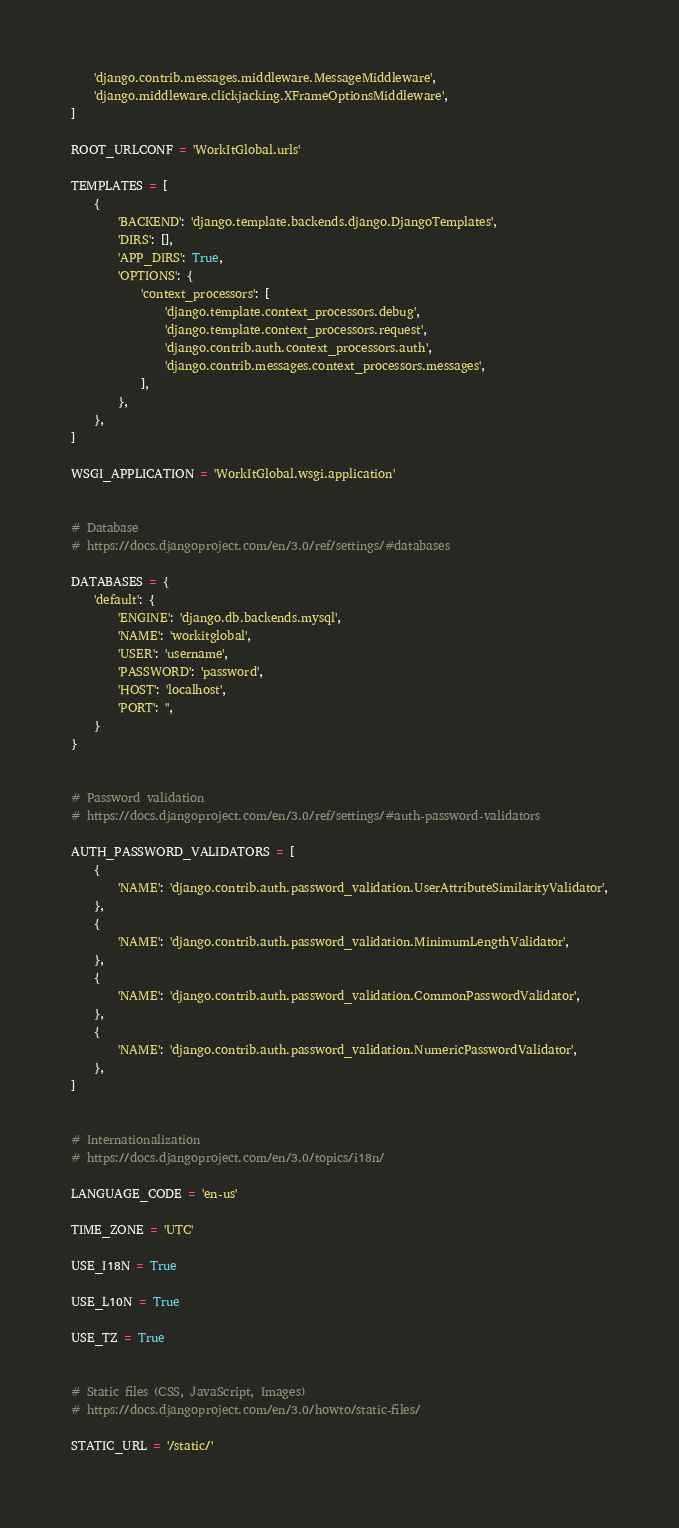Convert code to text. <code><loc_0><loc_0><loc_500><loc_500><_Python_>    'django.contrib.messages.middleware.MessageMiddleware',
    'django.middleware.clickjacking.XFrameOptionsMiddleware',
]

ROOT_URLCONF = 'WorkItGlobal.urls'

TEMPLATES = [
    {
        'BACKEND': 'django.template.backends.django.DjangoTemplates',
        'DIRS': [],
        'APP_DIRS': True,
        'OPTIONS': {
            'context_processors': [
                'django.template.context_processors.debug',
                'django.template.context_processors.request',
                'django.contrib.auth.context_processors.auth',
                'django.contrib.messages.context_processors.messages',
            ],
        },
    },
]

WSGI_APPLICATION = 'WorkItGlobal.wsgi.application'


# Database
# https://docs.djangoproject.com/en/3.0/ref/settings/#databases

DATABASES = {
    'default': {
        'ENGINE': 'django.db.backends.mysql',
        'NAME': 'workitglobal',
        'USER': 'username',
        'PASSWORD': 'password',
        'HOST': 'localhost',
        'PORT': '',
    }
}


# Password validation
# https://docs.djangoproject.com/en/3.0/ref/settings/#auth-password-validators

AUTH_PASSWORD_VALIDATORS = [
    {
        'NAME': 'django.contrib.auth.password_validation.UserAttributeSimilarityValidator',
    },
    {
        'NAME': 'django.contrib.auth.password_validation.MinimumLengthValidator',
    },
    {
        'NAME': 'django.contrib.auth.password_validation.CommonPasswordValidator',
    },
    {
        'NAME': 'django.contrib.auth.password_validation.NumericPasswordValidator',
    },
]


# Internationalization
# https://docs.djangoproject.com/en/3.0/topics/i18n/

LANGUAGE_CODE = 'en-us'

TIME_ZONE = 'UTC'

USE_I18N = True

USE_L10N = True

USE_TZ = True


# Static files (CSS, JavaScript, Images)
# https://docs.djangoproject.com/en/3.0/howto/static-files/

STATIC_URL = '/static/'
</code> 